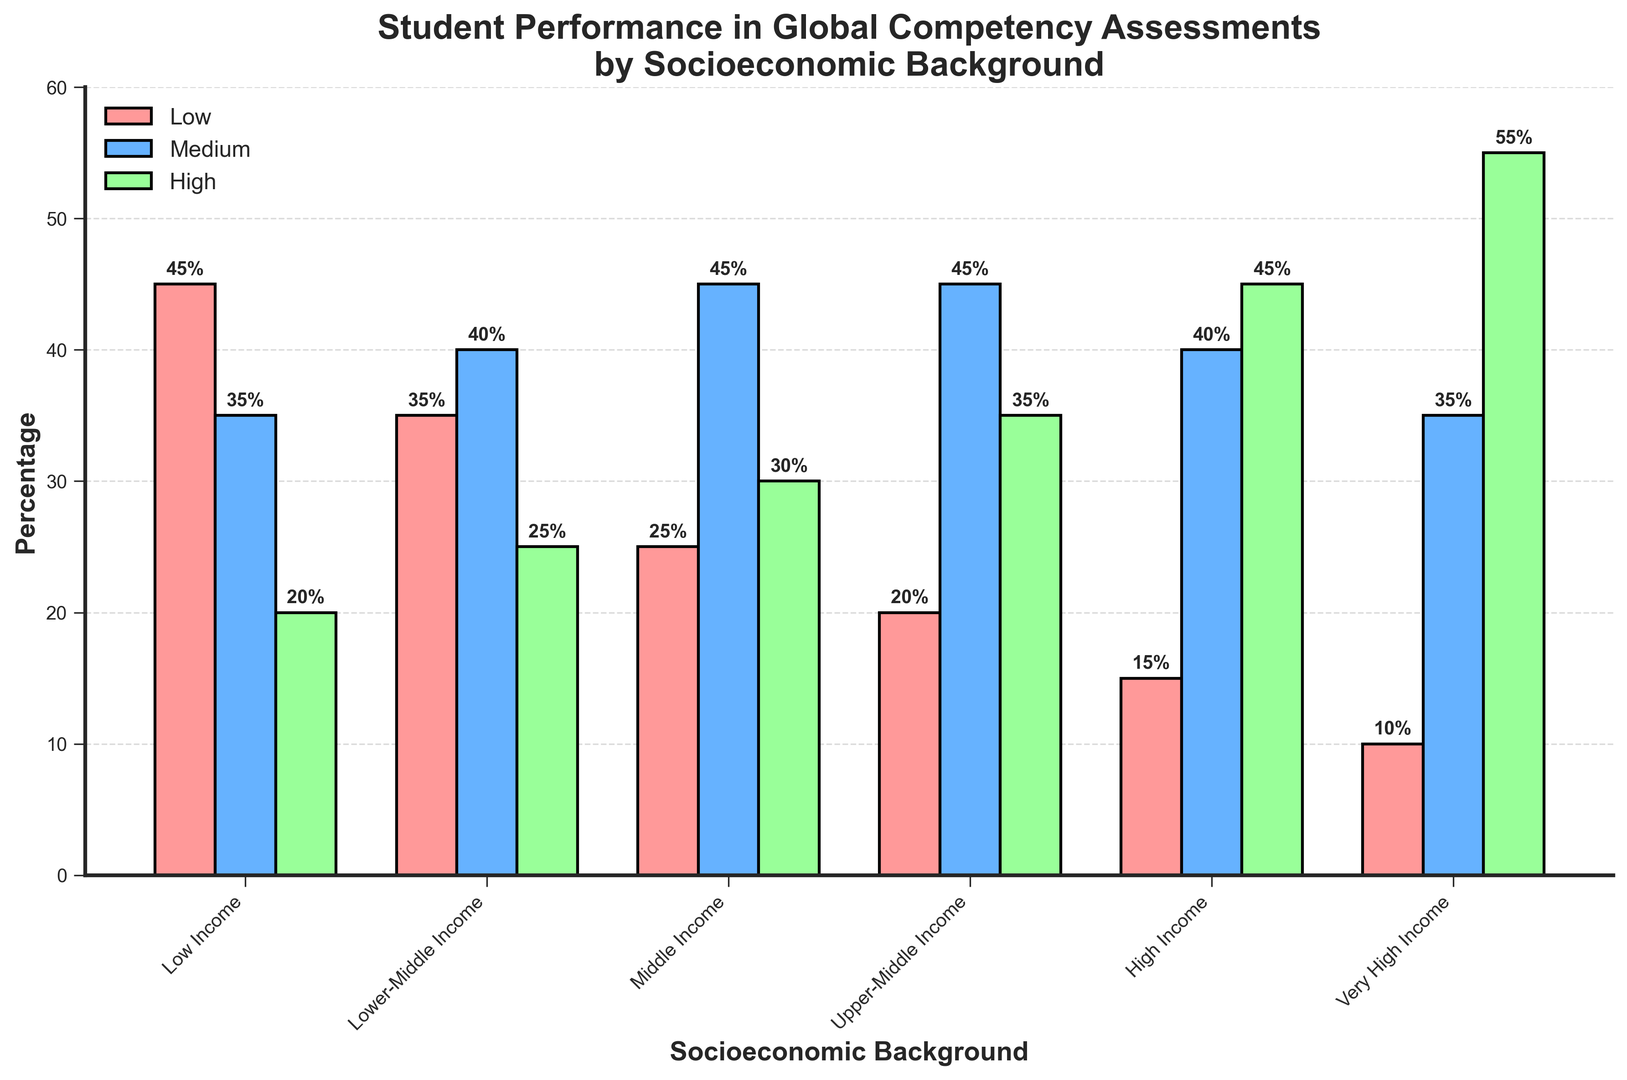Which socioeconomic group has the highest percentage of students with high global competency? From the figure, the height of the green bar representing "High Global Competency" is tallest for "Very High Income".
Answer: Very High Income What is the sum of percentages for students with low and medium global competency in the lower-middle-income group? The figure shows that the percentage of students with low global competency is 35 and with medium global competency is 40 for lower-middle income. Sum them up: 35 + 40 = 75.
Answer: 75 Which group shows the smallest percentage difference between students with medium and high global competency? The difference for each group is as follows: 
- Low Income: 35 - 20 = 15 
- Lower-Middle Income: 40 - 25 = 15 
- Middle Income: 45 - 30 = 15 
- Upper-Middle Income: 45 - 35 = 10 
- High Income: 40 - 45 = 5 
- Very High Income: 35 - 55 = 20 
Among these, "High Income" has the smallest difference of 5.
Answer: High Income How does the percentage of students with low global competency compare between the "Low Income" group and the "High Income" group? The percentage of students with low global competency in the "Low Income" group is 45, while it is 15 in the "High Income" group. 45 is greater than 15.
Answer: Low Income has a higher percentage What percentage of upper-middle-income students exhibit medium or high global competency? From the figure, for the upper-middle-income group, the medium competency is 45% and the high competency is 35%. Sum them up: 45 + 35 = 80.
Answer: 80 Which socioeconomic group has the most uniform distribution of global competency levels? The group where the bars for low, medium, and high global competency are closest in height is the "Lower-Middle Income" group with percentages 35, 40, and 25, respectively.
Answer: Lower-Middle Income What is the combined percentage of students with low global competency across all income groups? Sum the percentages of low global competency for each group: 
- Low Income: 45 
- Lower-Middle Income: 35 
- Middle Income: 25 
- Upper-Middle Income: 20 
- High Income: 15 
- Very High Income: 10
Total = 45 + 35 + 25 + 20 + 15 + 10 = 150.
Answer: 150 Is there any income group where more than half of the students exhibit high global competency? In the figure, only the "Very High Income" group shows that more than half of the students (55%) have high global competency.
Answer: Yes How does the percentage of students with medium global competency change as we move from "Low Income" to "Very High Income"? Observing the blue bars in the figure from left to right (Low Income to Very High Income), the percentages are: 35, 40, 45, 45, 40, 35. It initially increases to 45 and then decreases back to 35.
Answer: Increases then decreases In which income group is the difference between the percentages of students with low and high global competency the smallest? Calculate the differences for each group:
- Low Income: 45 - 20 = 25
- Lower-Middle Income: 35 - 25 = 10
- Middle Income: 25 - 30 = 5
- Upper-Middle Income: 20 - 35 = 15
- High Income: 15 - 45 = 30
- Very High Income: 10 - 55 = 45
The smallest difference is for "Middle Income" with a value of 5.
Answer: Middle Income 